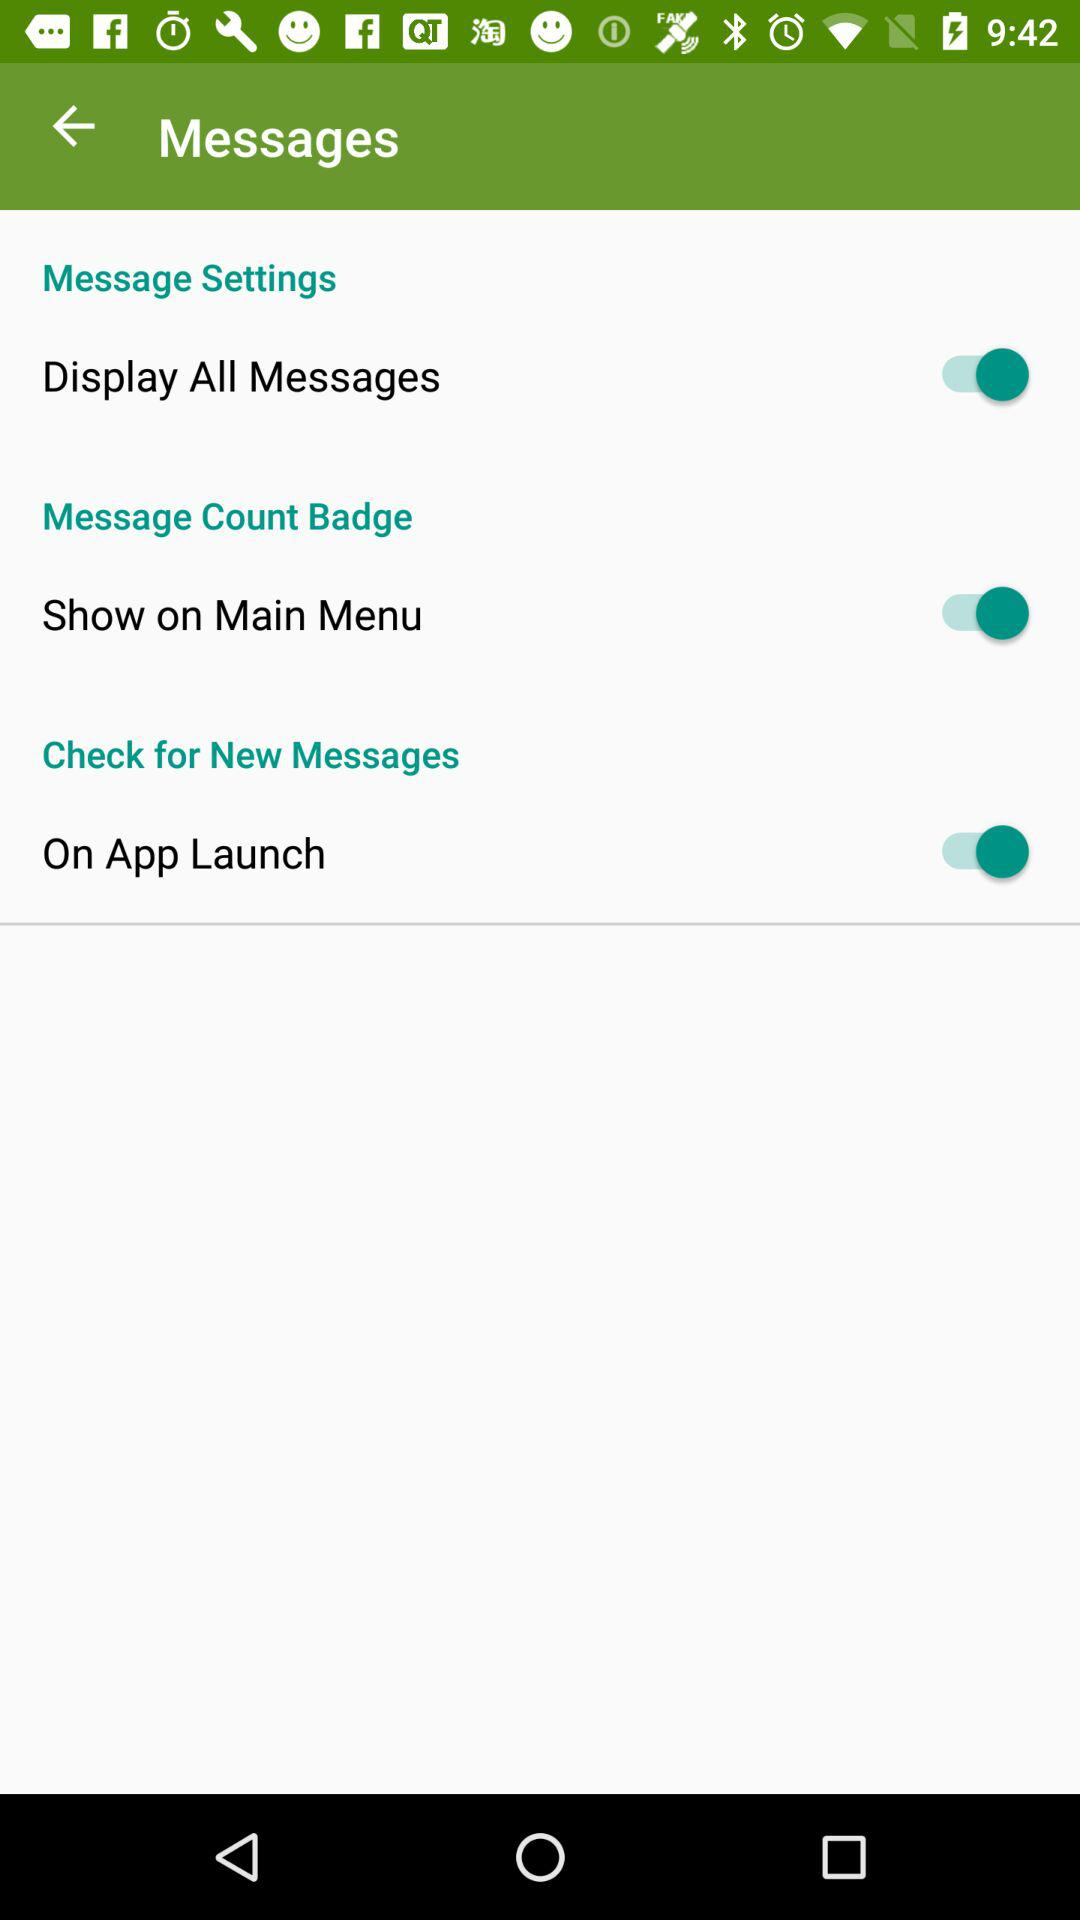What is the status of the "Show on Main Menu"? The status is "on". 